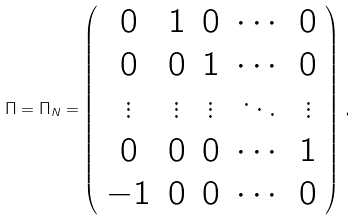<formula> <loc_0><loc_0><loc_500><loc_500>\Pi = \Pi _ { N } = \left ( \begin{array} { c c c c c } 0 & 1 & 0 & \cdots & 0 \\ 0 & 0 & 1 & \cdots & 0 \\ \vdots & \vdots & \vdots & \ddots & \vdots \\ 0 & 0 & 0 & \cdots & 1 \\ - 1 & 0 & 0 & \cdots & 0 \end{array} \right ) \, ,</formula> 